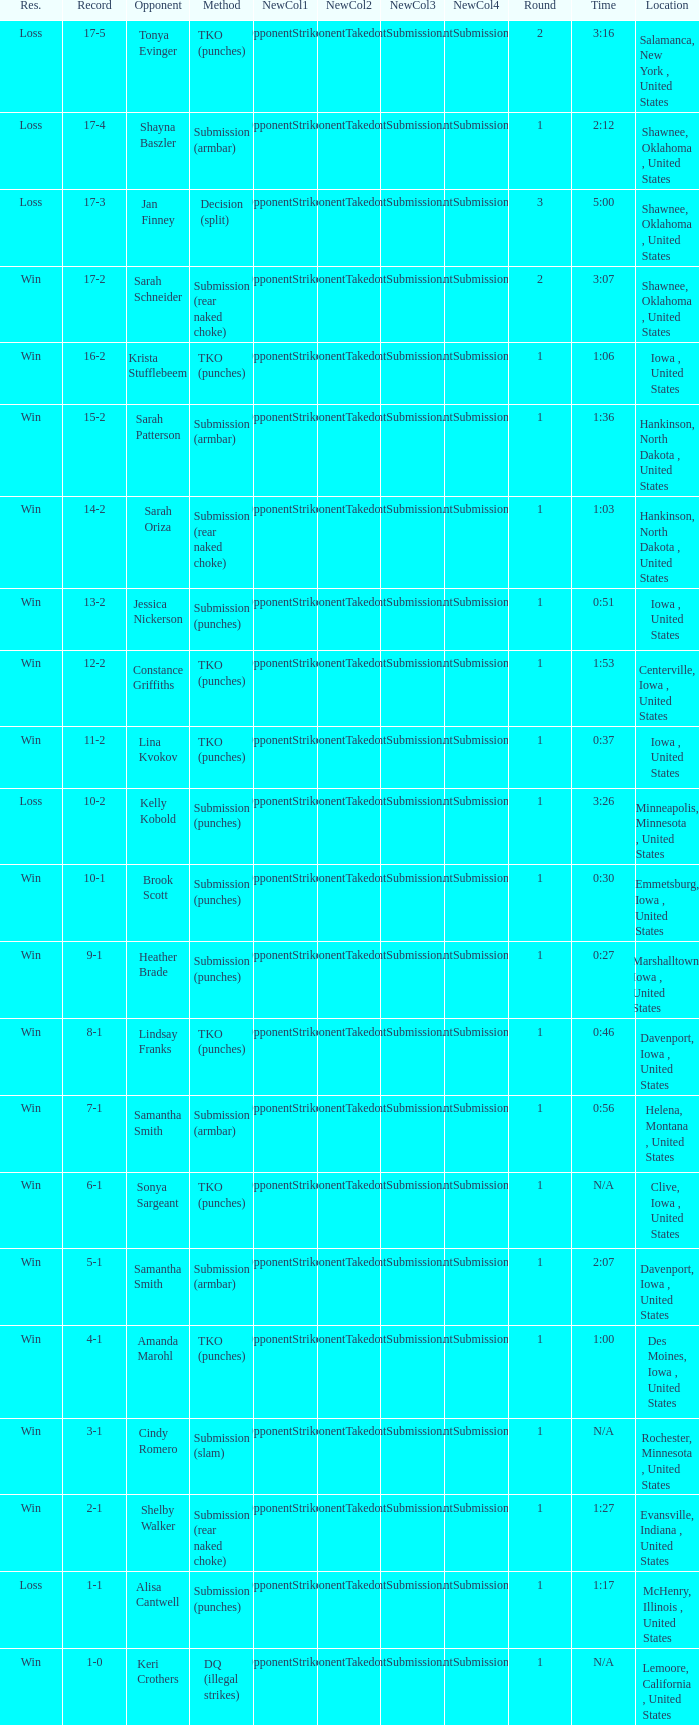What opponent does she fight when she is 10-1? Brook Scott. 